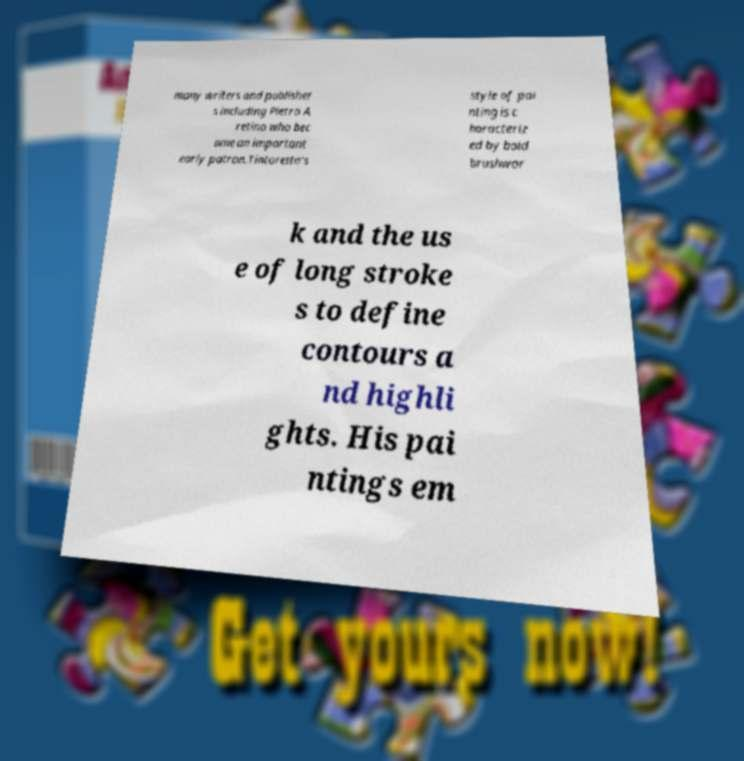There's text embedded in this image that I need extracted. Can you transcribe it verbatim? many writers and publisher s including Pietro A retino who bec ame an important early patron.Tintoretto's style of pai nting is c haracteriz ed by bold brushwor k and the us e of long stroke s to define contours a nd highli ghts. His pai ntings em 